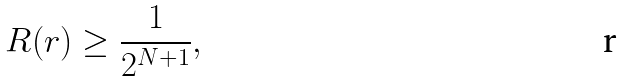<formula> <loc_0><loc_0><loc_500><loc_500>R ( r ) \geq \frac { 1 } { 2 ^ { N + 1 } } ,</formula> 